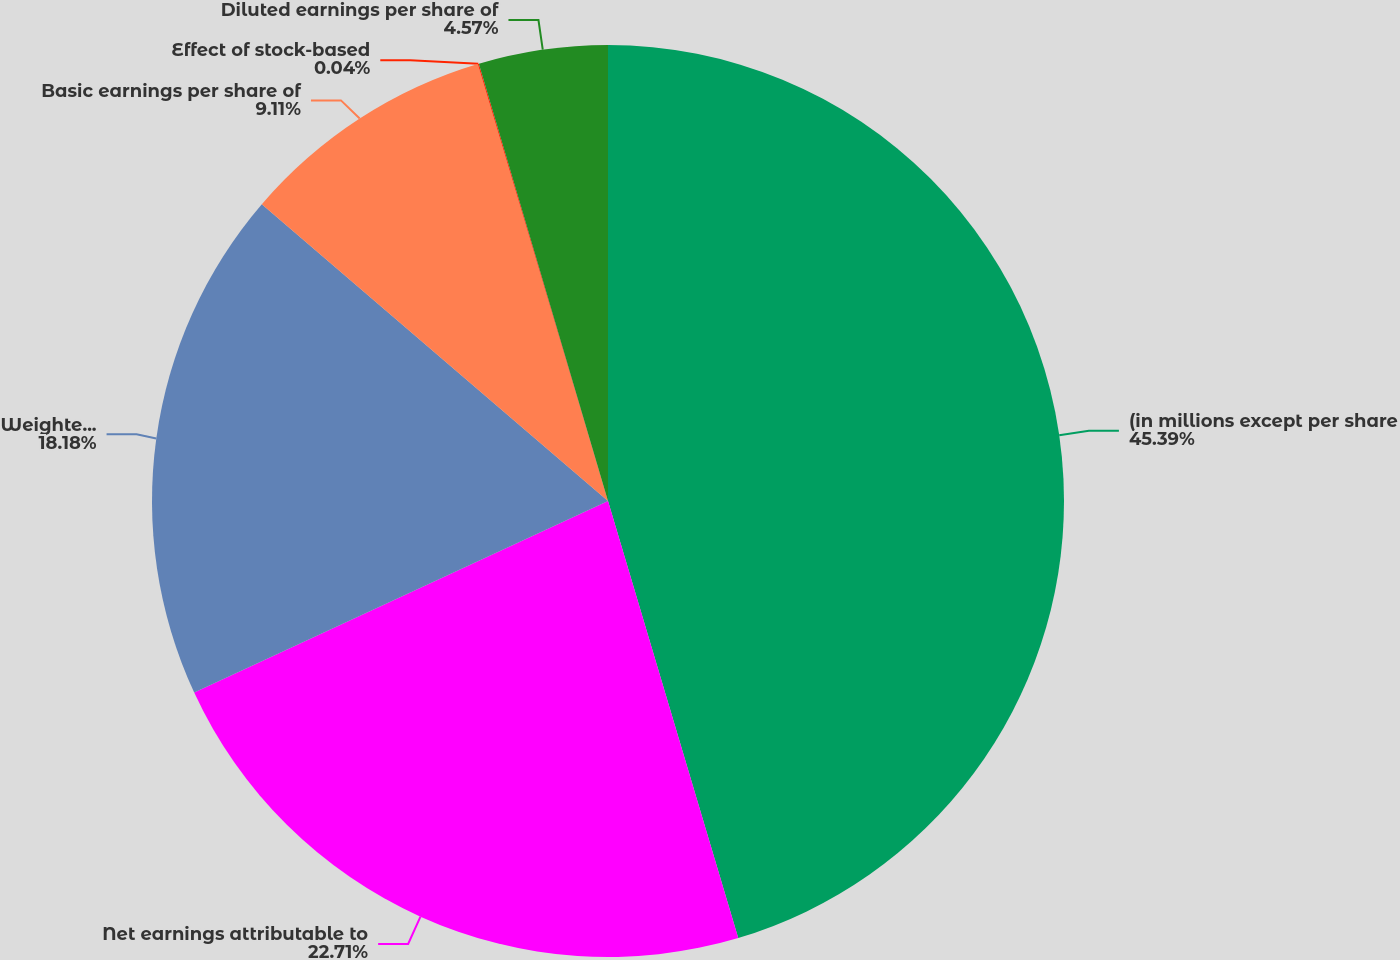Convert chart. <chart><loc_0><loc_0><loc_500><loc_500><pie_chart><fcel>(in millions except per share<fcel>Net earnings attributable to<fcel>Weighted average shares of<fcel>Basic earnings per share of<fcel>Effect of stock-based<fcel>Diluted earnings per share of<nl><fcel>45.39%<fcel>22.71%<fcel>18.18%<fcel>9.11%<fcel>0.04%<fcel>4.57%<nl></chart> 